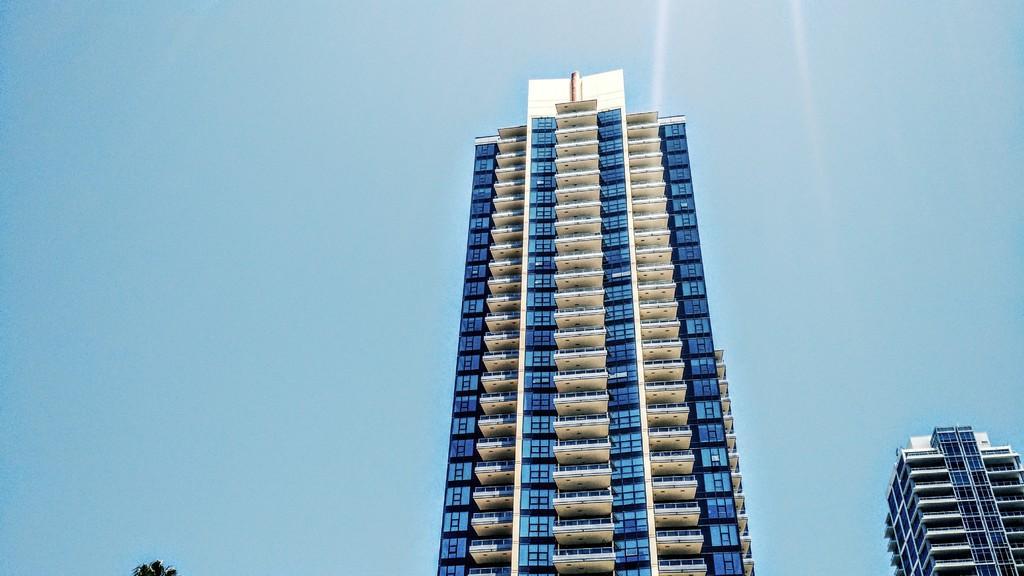Describe this image in one or two sentences. In this picture I can see there is a buildings here and there is a glass window here. The sky is clear. 